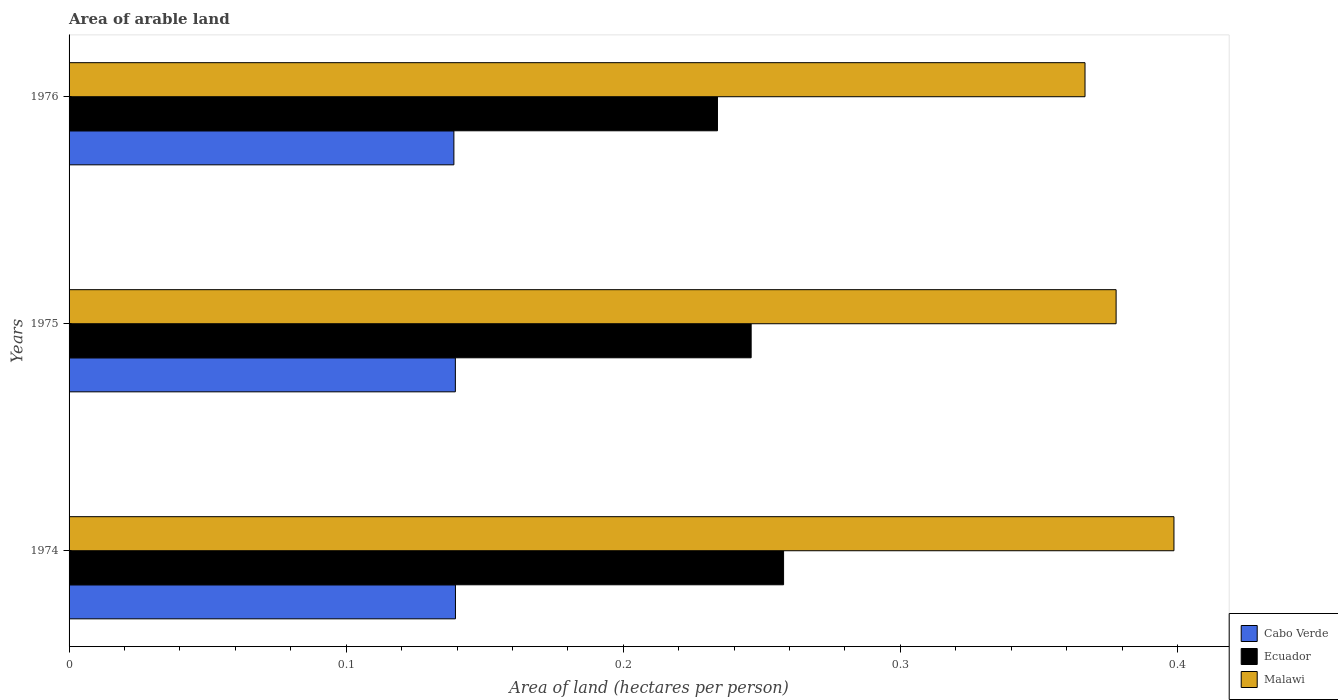How many different coloured bars are there?
Your response must be concise. 3. Are the number of bars per tick equal to the number of legend labels?
Ensure brevity in your answer.  Yes. Are the number of bars on each tick of the Y-axis equal?
Ensure brevity in your answer.  Yes. How many bars are there on the 3rd tick from the top?
Make the answer very short. 3. What is the label of the 2nd group of bars from the top?
Provide a succinct answer. 1975. What is the total arable land in Ecuador in 1974?
Provide a succinct answer. 0.26. Across all years, what is the maximum total arable land in Cabo Verde?
Give a very brief answer. 0.14. Across all years, what is the minimum total arable land in Cabo Verde?
Offer a terse response. 0.14. In which year was the total arable land in Malawi maximum?
Offer a very short reply. 1974. In which year was the total arable land in Cabo Verde minimum?
Provide a succinct answer. 1976. What is the total total arable land in Ecuador in the graph?
Your answer should be compact. 0.74. What is the difference between the total arable land in Malawi in 1975 and that in 1976?
Provide a short and direct response. 0.01. What is the difference between the total arable land in Malawi in 1975 and the total arable land in Ecuador in 1974?
Your answer should be very brief. 0.12. What is the average total arable land in Cabo Verde per year?
Give a very brief answer. 0.14. In the year 1976, what is the difference between the total arable land in Cabo Verde and total arable land in Ecuador?
Your answer should be very brief. -0.1. What is the ratio of the total arable land in Cabo Verde in 1974 to that in 1976?
Make the answer very short. 1. What is the difference between the highest and the second highest total arable land in Ecuador?
Ensure brevity in your answer.  0.01. What is the difference between the highest and the lowest total arable land in Malawi?
Your response must be concise. 0.03. In how many years, is the total arable land in Malawi greater than the average total arable land in Malawi taken over all years?
Your answer should be very brief. 1. Is the sum of the total arable land in Cabo Verde in 1975 and 1976 greater than the maximum total arable land in Ecuador across all years?
Offer a terse response. Yes. What does the 3rd bar from the top in 1975 represents?
Give a very brief answer. Cabo Verde. What does the 2nd bar from the bottom in 1975 represents?
Provide a short and direct response. Ecuador. How many bars are there?
Provide a succinct answer. 9. How many years are there in the graph?
Provide a succinct answer. 3. What is the difference between two consecutive major ticks on the X-axis?
Your response must be concise. 0.1. Are the values on the major ticks of X-axis written in scientific E-notation?
Provide a short and direct response. No. Does the graph contain any zero values?
Your response must be concise. No. Does the graph contain grids?
Give a very brief answer. No. Where does the legend appear in the graph?
Give a very brief answer. Bottom right. What is the title of the graph?
Offer a very short reply. Area of arable land. What is the label or title of the X-axis?
Ensure brevity in your answer.  Area of land (hectares per person). What is the label or title of the Y-axis?
Ensure brevity in your answer.  Years. What is the Area of land (hectares per person) in Cabo Verde in 1974?
Your answer should be very brief. 0.14. What is the Area of land (hectares per person) in Ecuador in 1974?
Give a very brief answer. 0.26. What is the Area of land (hectares per person) of Malawi in 1974?
Make the answer very short. 0.4. What is the Area of land (hectares per person) in Cabo Verde in 1975?
Ensure brevity in your answer.  0.14. What is the Area of land (hectares per person) of Ecuador in 1975?
Provide a short and direct response. 0.25. What is the Area of land (hectares per person) in Malawi in 1975?
Keep it short and to the point. 0.38. What is the Area of land (hectares per person) of Cabo Verde in 1976?
Provide a succinct answer. 0.14. What is the Area of land (hectares per person) of Ecuador in 1976?
Your answer should be very brief. 0.23. What is the Area of land (hectares per person) of Malawi in 1976?
Your answer should be compact. 0.37. Across all years, what is the maximum Area of land (hectares per person) in Cabo Verde?
Give a very brief answer. 0.14. Across all years, what is the maximum Area of land (hectares per person) in Ecuador?
Your answer should be very brief. 0.26. Across all years, what is the maximum Area of land (hectares per person) in Malawi?
Make the answer very short. 0.4. Across all years, what is the minimum Area of land (hectares per person) in Cabo Verde?
Give a very brief answer. 0.14. Across all years, what is the minimum Area of land (hectares per person) in Ecuador?
Ensure brevity in your answer.  0.23. Across all years, what is the minimum Area of land (hectares per person) in Malawi?
Your answer should be very brief. 0.37. What is the total Area of land (hectares per person) of Cabo Verde in the graph?
Provide a short and direct response. 0.42. What is the total Area of land (hectares per person) of Ecuador in the graph?
Keep it short and to the point. 0.74. What is the total Area of land (hectares per person) of Malawi in the graph?
Your response must be concise. 1.14. What is the difference between the Area of land (hectares per person) in Ecuador in 1974 and that in 1975?
Provide a short and direct response. 0.01. What is the difference between the Area of land (hectares per person) of Malawi in 1974 and that in 1975?
Keep it short and to the point. 0.02. What is the difference between the Area of land (hectares per person) of Cabo Verde in 1974 and that in 1976?
Your answer should be very brief. 0. What is the difference between the Area of land (hectares per person) of Ecuador in 1974 and that in 1976?
Your response must be concise. 0.02. What is the difference between the Area of land (hectares per person) of Malawi in 1974 and that in 1976?
Provide a short and direct response. 0.03. What is the difference between the Area of land (hectares per person) in Cabo Verde in 1975 and that in 1976?
Offer a very short reply. 0. What is the difference between the Area of land (hectares per person) of Ecuador in 1975 and that in 1976?
Offer a terse response. 0.01. What is the difference between the Area of land (hectares per person) in Malawi in 1975 and that in 1976?
Your answer should be very brief. 0.01. What is the difference between the Area of land (hectares per person) in Cabo Verde in 1974 and the Area of land (hectares per person) in Ecuador in 1975?
Offer a terse response. -0.11. What is the difference between the Area of land (hectares per person) of Cabo Verde in 1974 and the Area of land (hectares per person) of Malawi in 1975?
Offer a terse response. -0.24. What is the difference between the Area of land (hectares per person) of Ecuador in 1974 and the Area of land (hectares per person) of Malawi in 1975?
Give a very brief answer. -0.12. What is the difference between the Area of land (hectares per person) in Cabo Verde in 1974 and the Area of land (hectares per person) in Ecuador in 1976?
Give a very brief answer. -0.09. What is the difference between the Area of land (hectares per person) in Cabo Verde in 1974 and the Area of land (hectares per person) in Malawi in 1976?
Make the answer very short. -0.23. What is the difference between the Area of land (hectares per person) in Ecuador in 1974 and the Area of land (hectares per person) in Malawi in 1976?
Ensure brevity in your answer.  -0.11. What is the difference between the Area of land (hectares per person) in Cabo Verde in 1975 and the Area of land (hectares per person) in Ecuador in 1976?
Give a very brief answer. -0.09. What is the difference between the Area of land (hectares per person) of Cabo Verde in 1975 and the Area of land (hectares per person) of Malawi in 1976?
Your answer should be compact. -0.23. What is the difference between the Area of land (hectares per person) in Ecuador in 1975 and the Area of land (hectares per person) in Malawi in 1976?
Provide a succinct answer. -0.12. What is the average Area of land (hectares per person) in Cabo Verde per year?
Your answer should be very brief. 0.14. What is the average Area of land (hectares per person) of Ecuador per year?
Your answer should be compact. 0.25. What is the average Area of land (hectares per person) of Malawi per year?
Your answer should be compact. 0.38. In the year 1974, what is the difference between the Area of land (hectares per person) of Cabo Verde and Area of land (hectares per person) of Ecuador?
Keep it short and to the point. -0.12. In the year 1974, what is the difference between the Area of land (hectares per person) of Cabo Verde and Area of land (hectares per person) of Malawi?
Ensure brevity in your answer.  -0.26. In the year 1974, what is the difference between the Area of land (hectares per person) of Ecuador and Area of land (hectares per person) of Malawi?
Offer a terse response. -0.14. In the year 1975, what is the difference between the Area of land (hectares per person) of Cabo Verde and Area of land (hectares per person) of Ecuador?
Your answer should be very brief. -0.11. In the year 1975, what is the difference between the Area of land (hectares per person) in Cabo Verde and Area of land (hectares per person) in Malawi?
Offer a terse response. -0.24. In the year 1975, what is the difference between the Area of land (hectares per person) in Ecuador and Area of land (hectares per person) in Malawi?
Ensure brevity in your answer.  -0.13. In the year 1976, what is the difference between the Area of land (hectares per person) of Cabo Verde and Area of land (hectares per person) of Ecuador?
Keep it short and to the point. -0.1. In the year 1976, what is the difference between the Area of land (hectares per person) of Cabo Verde and Area of land (hectares per person) of Malawi?
Make the answer very short. -0.23. In the year 1976, what is the difference between the Area of land (hectares per person) in Ecuador and Area of land (hectares per person) in Malawi?
Your answer should be very brief. -0.13. What is the ratio of the Area of land (hectares per person) in Cabo Verde in 1974 to that in 1975?
Your response must be concise. 1. What is the ratio of the Area of land (hectares per person) in Ecuador in 1974 to that in 1975?
Ensure brevity in your answer.  1.05. What is the ratio of the Area of land (hectares per person) in Malawi in 1974 to that in 1975?
Give a very brief answer. 1.06. What is the ratio of the Area of land (hectares per person) of Ecuador in 1974 to that in 1976?
Your response must be concise. 1.1. What is the ratio of the Area of land (hectares per person) in Malawi in 1974 to that in 1976?
Ensure brevity in your answer.  1.09. What is the ratio of the Area of land (hectares per person) in Cabo Verde in 1975 to that in 1976?
Your response must be concise. 1. What is the ratio of the Area of land (hectares per person) of Ecuador in 1975 to that in 1976?
Your response must be concise. 1.05. What is the ratio of the Area of land (hectares per person) of Malawi in 1975 to that in 1976?
Your answer should be compact. 1.03. What is the difference between the highest and the second highest Area of land (hectares per person) in Ecuador?
Your answer should be very brief. 0.01. What is the difference between the highest and the second highest Area of land (hectares per person) of Malawi?
Provide a succinct answer. 0.02. What is the difference between the highest and the lowest Area of land (hectares per person) in Cabo Verde?
Offer a terse response. 0. What is the difference between the highest and the lowest Area of land (hectares per person) in Ecuador?
Offer a terse response. 0.02. What is the difference between the highest and the lowest Area of land (hectares per person) of Malawi?
Offer a terse response. 0.03. 